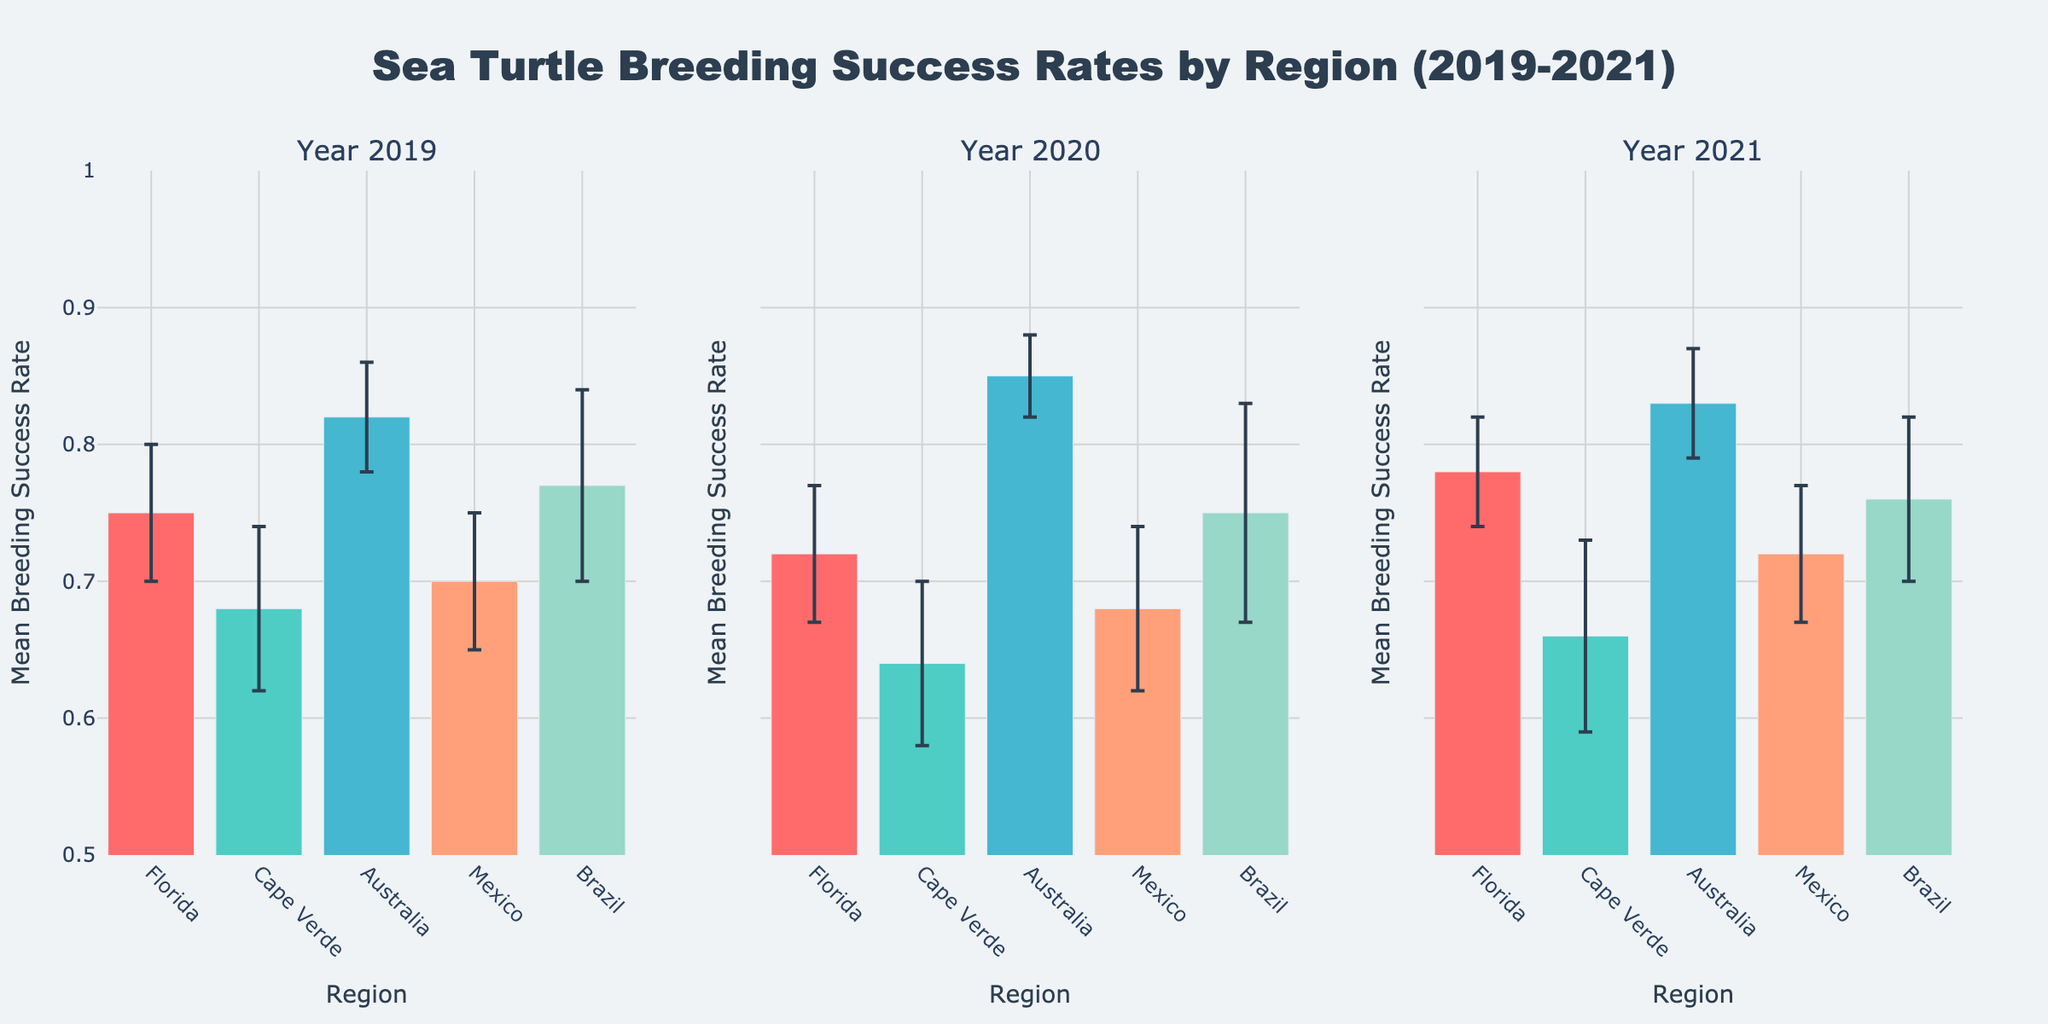What's the title of the figure? The title is displayed at the top of the figure, describing what the plot represents.
Answer: Sea Turtle Breeding Success Rates by Region (2019-2021) Which region had the highest mean breeding success rate in 2020? Look at the bar plot for the year 2020 and identify the tallest bar. Australia has the highest mean breeding success rate.
Answer: Australia How does the mean breeding success rate in Florida change from 2019 to 2021? Compare the heights of the bars for Florida across the three years. The rate decreases from 0.75 in 2019 to 0.72 in 2020, then increases to 0.78 in 2021.
Answer: Decreases, then increases Which year had the lowest mean breeding success rate in Cape Verde? Compare the heights of the bars for Cape Verde across the three years. The year 2020 had the lowest rate at 0.64.
Answer: 2020 What is the mean breeding success rate for Mexico in 2021? Identify the height of the bar for Mexico in the subplot corresponding to the year 2021. The rate is 0.72.
Answer: 0.72 Which region shows the least year-to-year variability in mean breeding success rate? Compare the relative changes and error bars for each region across the three subplots. Australia shows the least variability with consistent high success rates and smaller error bars.
Answer: Australia How does the mean breeding success rate in Brazil vary between 2019 and 2020? Compare the heights of the bars for Brazil in the subplots for 2019 and 2020. The rate decreases from 0.77 in 2019 to 0.75 in 2020.
Answer: Decreases What is the average breeding success rate in Australia across all three years? Sum the breeding success rates for Australia for the years 2019 (0.82), 2020 (0.85), and 2021 (0.83) and then divide by 3. The average is (0.82 + 0.85 + 0.83) / 3 = 0.833.
Answer: 0.833 Which region had the greatest standard deviation in breeding success rate in 2020? Check the length of the error bars in the subplot for the year 2020. Brazil has the greatest standard deviation with an error bar length of 0.08.
Answer: Brazil 